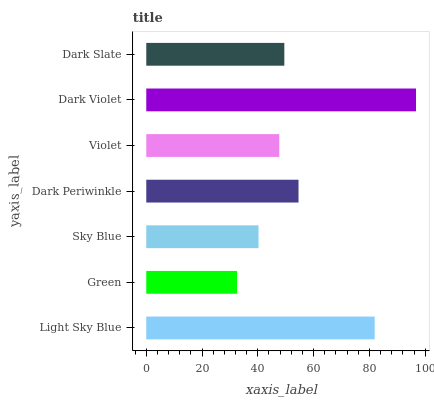Is Green the minimum?
Answer yes or no. Yes. Is Dark Violet the maximum?
Answer yes or no. Yes. Is Sky Blue the minimum?
Answer yes or no. No. Is Sky Blue the maximum?
Answer yes or no. No. Is Sky Blue greater than Green?
Answer yes or no. Yes. Is Green less than Sky Blue?
Answer yes or no. Yes. Is Green greater than Sky Blue?
Answer yes or no. No. Is Sky Blue less than Green?
Answer yes or no. No. Is Dark Slate the high median?
Answer yes or no. Yes. Is Dark Slate the low median?
Answer yes or no. Yes. Is Green the high median?
Answer yes or no. No. Is Dark Periwinkle the low median?
Answer yes or no. No. 